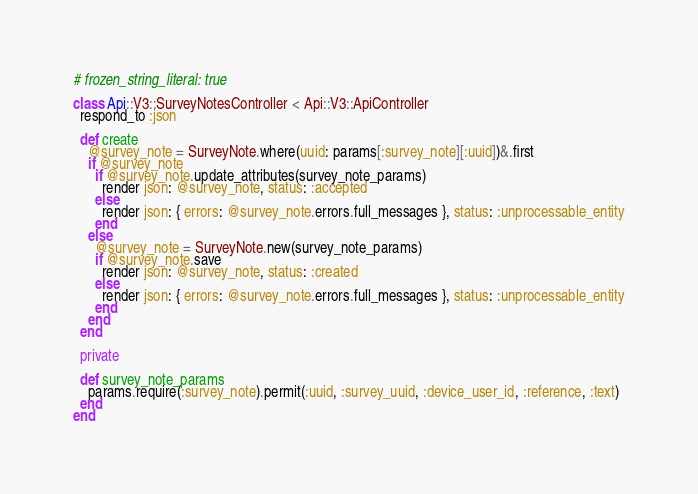Convert code to text. <code><loc_0><loc_0><loc_500><loc_500><_Ruby_># frozen_string_literal: true

class Api::V3::SurveyNotesController < Api::V3::ApiController
  respond_to :json

  def create
    @survey_note = SurveyNote.where(uuid: params[:survey_note][:uuid])&.first
    if @survey_note
      if @survey_note.update_attributes(survey_note_params)
        render json: @survey_note, status: :accepted
      else
        render json: { errors: @survey_note.errors.full_messages }, status: :unprocessable_entity
      end
    else
      @survey_note = SurveyNote.new(survey_note_params)
      if @survey_note.save
        render json: @survey_note, status: :created
      else
        render json: { errors: @survey_note.errors.full_messages }, status: :unprocessable_entity
      end
    end
  end

  private

  def survey_note_params
    params.require(:survey_note).permit(:uuid, :survey_uuid, :device_user_id, :reference, :text)
  end
end
</code> 